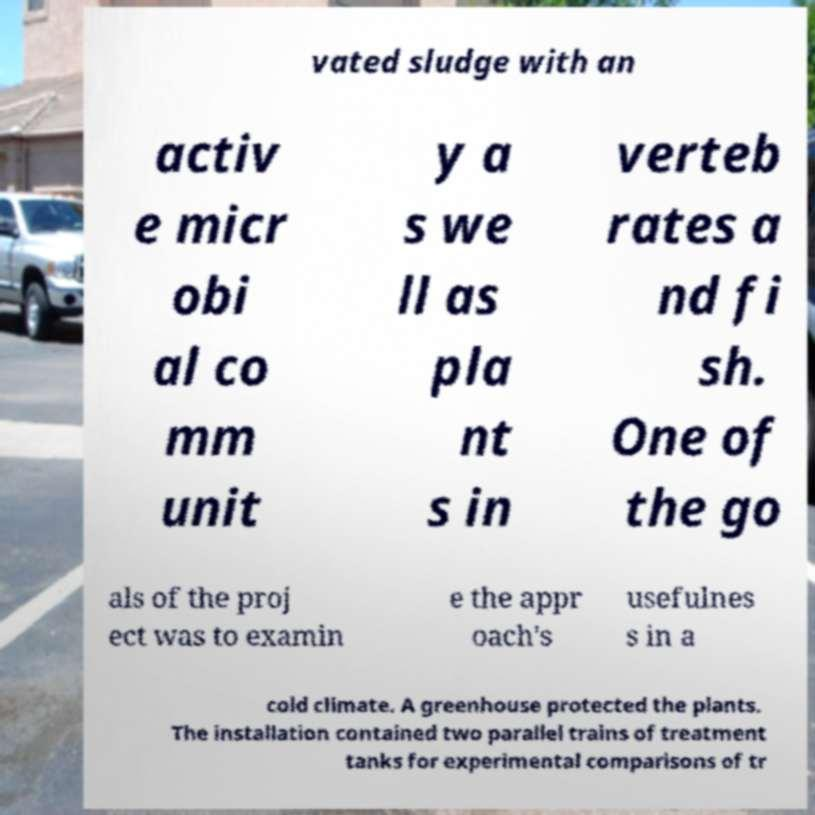Could you assist in decoding the text presented in this image and type it out clearly? vated sludge with an activ e micr obi al co mm unit y a s we ll as pla nt s in verteb rates a nd fi sh. One of the go als of the proj ect was to examin e the appr oach's usefulnes s in a cold climate. A greenhouse protected the plants. The installation contained two parallel trains of treatment tanks for experimental comparisons of tr 